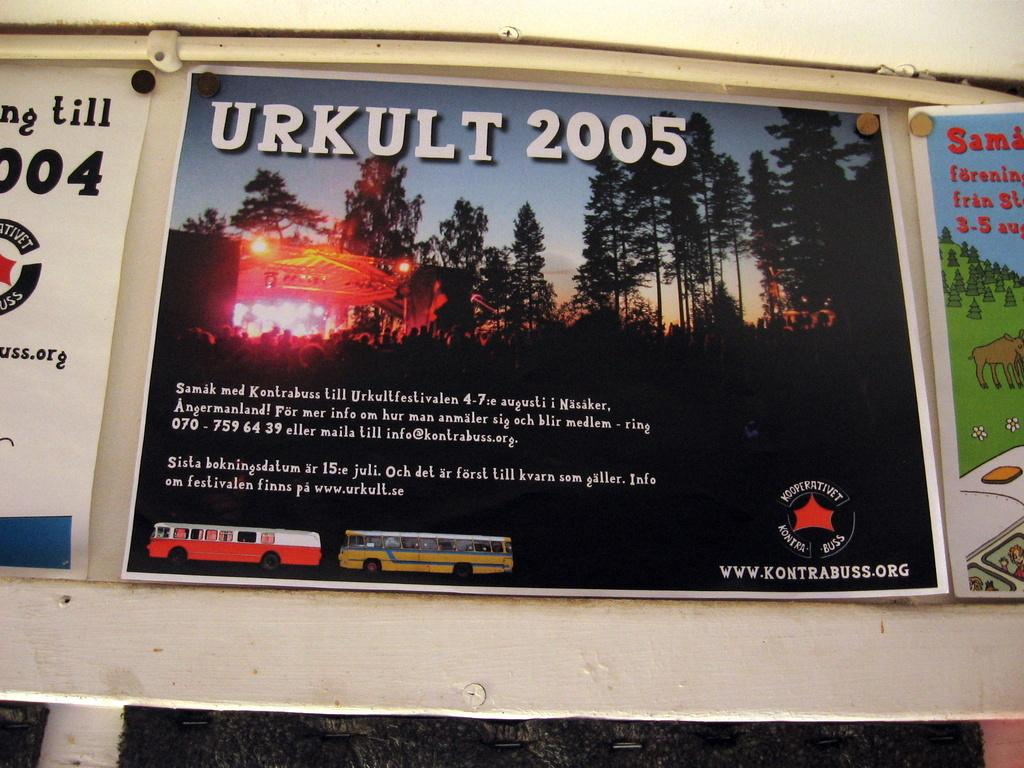<image>
Give a short and clear explanation of the subsequent image. An advertisment that says Urkult 2005 across the top. 